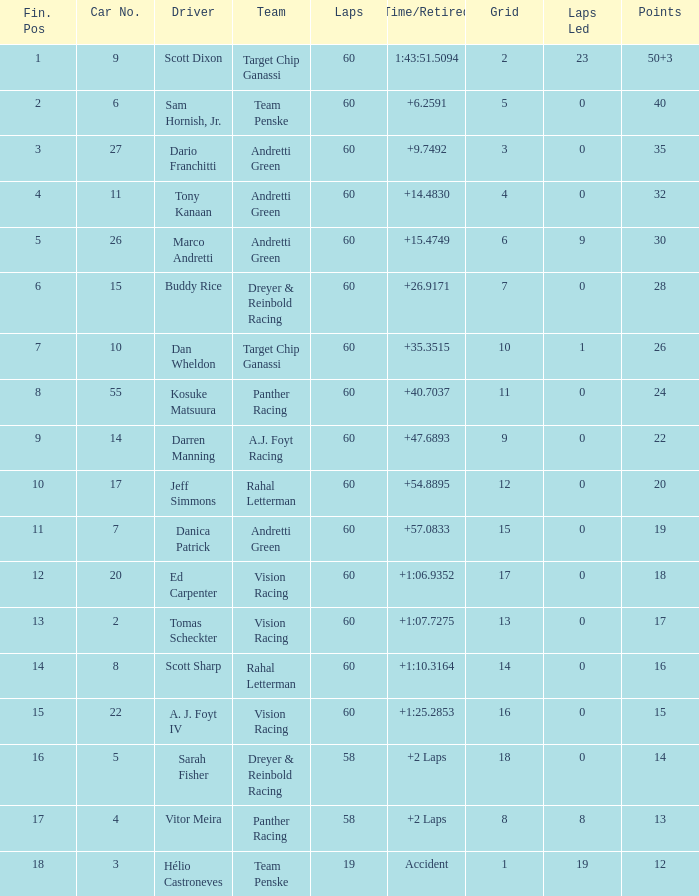Name the team of darren manning A.J. Foyt Racing. 